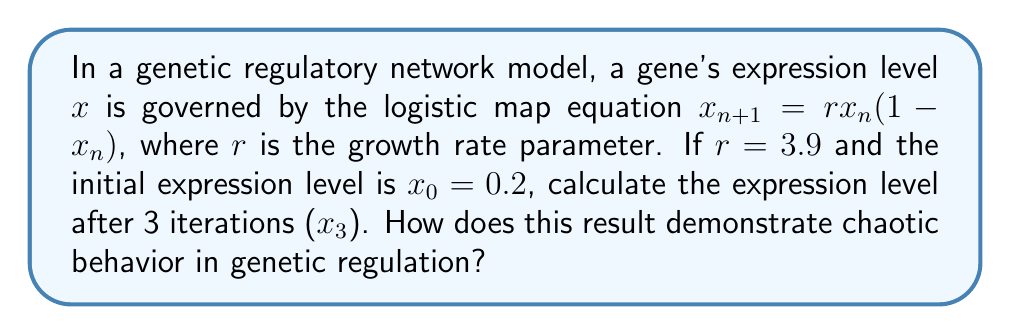Teach me how to tackle this problem. To solve this problem, we'll iterate the logistic map equation three times:

1. First iteration ($n = 0$ to $n = 1$):
   $$x_1 = rx_0(1-x_0) = 3.9 \cdot 0.2 \cdot (1-0.2) = 3.9 \cdot 0.2 \cdot 0.8 = 0.624$$

2. Second iteration ($n = 1$ to $n = 2$):
   $$x_2 = rx_1(1-x_1) = 3.9 \cdot 0.624 \cdot (1-0.624) = 3.9 \cdot 0.624 \cdot 0.376 = 0.917856$$

3. Third iteration ($n = 2$ to $n = 3$):
   $$x_3 = rx_2(1-x_2) = 3.9 \cdot 0.917856 \cdot (1-0.917856) = 3.9 \cdot 0.917856 \cdot 0.082144 = 0.294188$$

This result demonstrates chaotic behavior in genetic regulation because:

1. Sensitivity to initial conditions: Small changes in the initial value $x_0$ would lead to significantly different outcomes after just a few iterations.

2. Aperiodic behavior: The gene expression levels do not settle into a stable pattern or fixed point, instead exhibiting irregular fluctuations.

3. Bounded but unpredictable: The expression levels remain within the range [0, 1] but are difficult to predict long-term without precise calculations.

4. Complex dynamics: The system exhibits nonlinear behavior, with the growth rate parameter $r = 3.9$ placing it in the chaotic regime of the logistic map.

These characteristics align with chaos theory principles, suggesting that genetic regulatory networks can display chaotic dynamics, potentially explaining the complexity and variability observed in gene expression patterns.
Answer: $x_3 = 0.294188$; demonstrates chaos via sensitivity to initial conditions, aperiodicity, boundedness, and complex dynamics. 